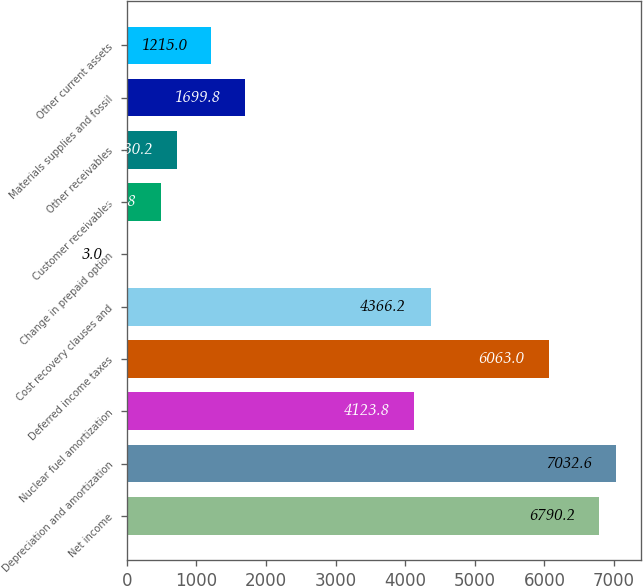Convert chart to OTSL. <chart><loc_0><loc_0><loc_500><loc_500><bar_chart><fcel>Net income<fcel>Depreciation and amortization<fcel>Nuclear fuel amortization<fcel>Deferred income taxes<fcel>Cost recovery clauses and<fcel>Change in prepaid option<fcel>Customer receivables<fcel>Other receivables<fcel>Materials supplies and fossil<fcel>Other current assets<nl><fcel>6790.2<fcel>7032.6<fcel>4123.8<fcel>6063<fcel>4366.2<fcel>3<fcel>487.8<fcel>730.2<fcel>1699.8<fcel>1215<nl></chart> 